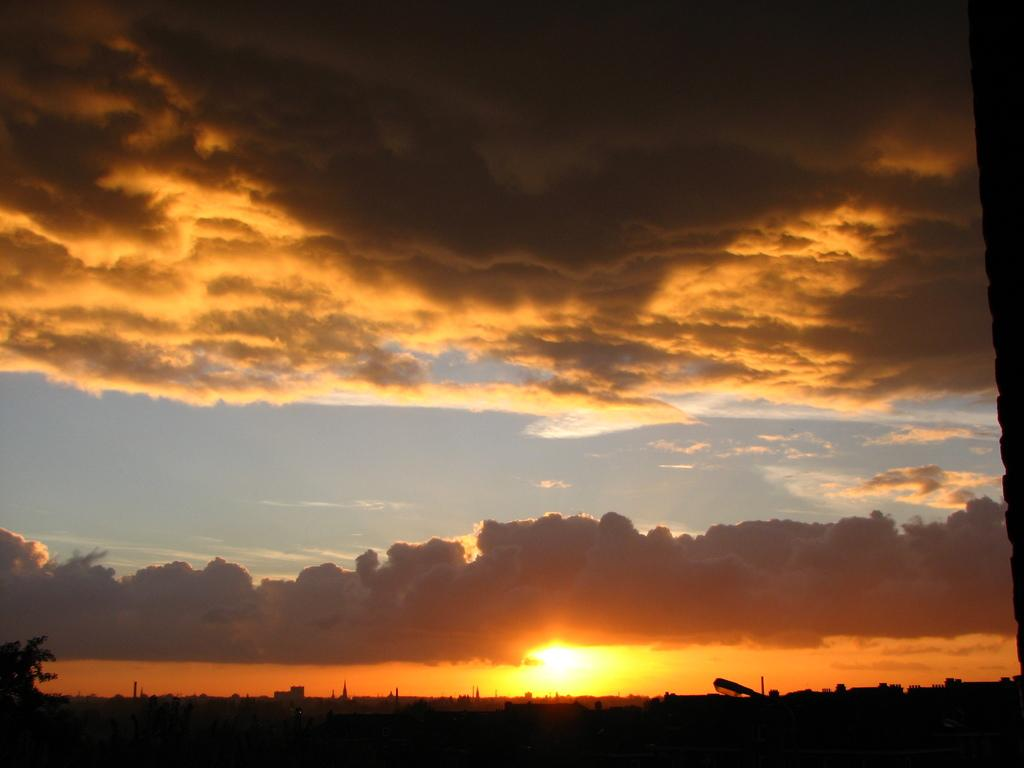What type of plant can be seen in the image? There is a tree in the image. What structure is also present in the image? There is a light pole in the image. What can be seen in the sky in the image? The sun is visible in the sky, and there are clouds present as well. What type of lettuce can be seen growing near the tree in the image? There is no lettuce present in the image; it only features a tree and a light pole. Can you tell me the grade of the ocean visible in the image? There is no ocean present in the image; it only features a tree, a light pole, and the sky. 